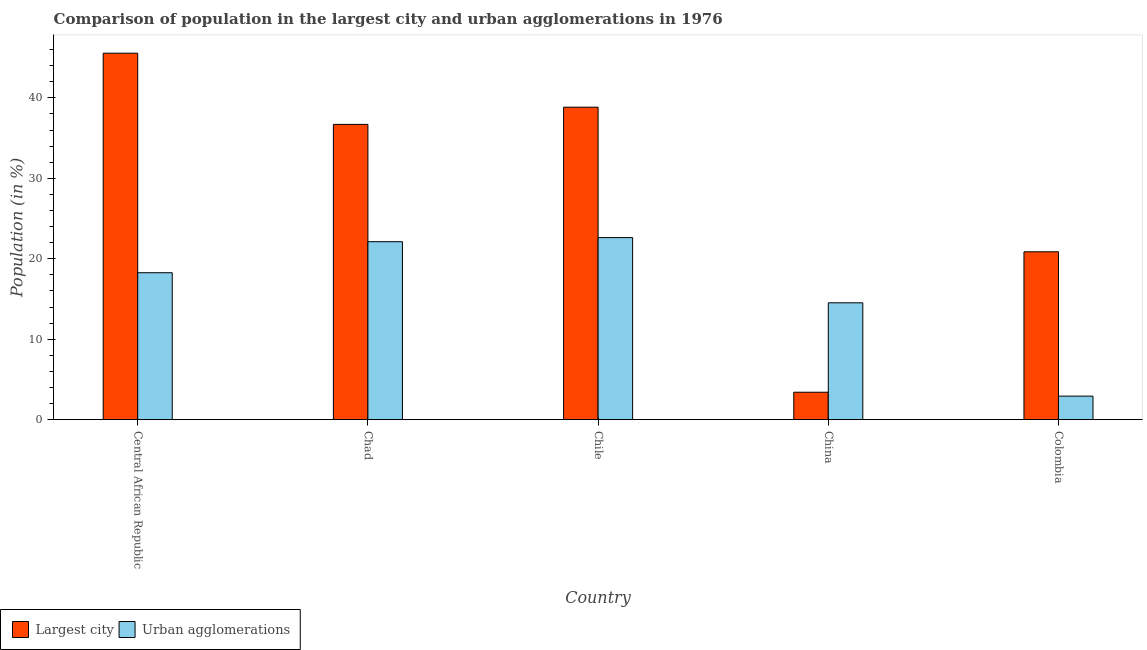Are the number of bars per tick equal to the number of legend labels?
Keep it short and to the point. Yes. In how many cases, is the number of bars for a given country not equal to the number of legend labels?
Your answer should be compact. 0. What is the population in urban agglomerations in Chile?
Provide a short and direct response. 22.63. Across all countries, what is the maximum population in the largest city?
Provide a succinct answer. 45.55. Across all countries, what is the minimum population in the largest city?
Give a very brief answer. 3.41. In which country was the population in urban agglomerations maximum?
Provide a short and direct response. Chile. In which country was the population in urban agglomerations minimum?
Provide a succinct answer. Colombia. What is the total population in the largest city in the graph?
Make the answer very short. 145.37. What is the difference between the population in urban agglomerations in Central African Republic and that in Chile?
Offer a very short reply. -4.37. What is the difference between the population in the largest city in China and the population in urban agglomerations in Central African Republic?
Ensure brevity in your answer.  -14.85. What is the average population in the largest city per country?
Offer a very short reply. 29.07. What is the difference between the population in urban agglomerations and population in the largest city in China?
Offer a very short reply. 11.11. In how many countries, is the population in the largest city greater than 32 %?
Give a very brief answer. 3. What is the ratio of the population in the largest city in Chile to that in China?
Offer a very short reply. 11.38. What is the difference between the highest and the second highest population in urban agglomerations?
Your answer should be compact. 0.51. What is the difference between the highest and the lowest population in urban agglomerations?
Your answer should be very brief. 19.7. What does the 1st bar from the left in Chad represents?
Make the answer very short. Largest city. What does the 2nd bar from the right in Colombia represents?
Your answer should be very brief. Largest city. How many bars are there?
Your answer should be very brief. 10. What is the difference between two consecutive major ticks on the Y-axis?
Offer a terse response. 10. Are the values on the major ticks of Y-axis written in scientific E-notation?
Provide a short and direct response. No. How are the legend labels stacked?
Your answer should be compact. Horizontal. What is the title of the graph?
Your response must be concise. Comparison of population in the largest city and urban agglomerations in 1976. Does "Birth rate" appear as one of the legend labels in the graph?
Provide a succinct answer. No. What is the Population (in %) in Largest city in Central African Republic?
Make the answer very short. 45.55. What is the Population (in %) in Urban agglomerations in Central African Republic?
Your answer should be very brief. 18.27. What is the Population (in %) of Largest city in Chad?
Make the answer very short. 36.7. What is the Population (in %) of Urban agglomerations in Chad?
Give a very brief answer. 22.12. What is the Population (in %) of Largest city in Chile?
Provide a succinct answer. 38.84. What is the Population (in %) in Urban agglomerations in Chile?
Make the answer very short. 22.63. What is the Population (in %) in Largest city in China?
Your response must be concise. 3.41. What is the Population (in %) of Urban agglomerations in China?
Your answer should be compact. 14.53. What is the Population (in %) of Largest city in Colombia?
Make the answer very short. 20.87. What is the Population (in %) of Urban agglomerations in Colombia?
Offer a very short reply. 2.93. Across all countries, what is the maximum Population (in %) of Largest city?
Provide a short and direct response. 45.55. Across all countries, what is the maximum Population (in %) in Urban agglomerations?
Offer a very short reply. 22.63. Across all countries, what is the minimum Population (in %) in Largest city?
Keep it short and to the point. 3.41. Across all countries, what is the minimum Population (in %) of Urban agglomerations?
Offer a very short reply. 2.93. What is the total Population (in %) of Largest city in the graph?
Provide a short and direct response. 145.37. What is the total Population (in %) of Urban agglomerations in the graph?
Make the answer very short. 80.48. What is the difference between the Population (in %) in Largest city in Central African Republic and that in Chad?
Ensure brevity in your answer.  8.85. What is the difference between the Population (in %) of Urban agglomerations in Central African Republic and that in Chad?
Provide a short and direct response. -3.86. What is the difference between the Population (in %) of Largest city in Central African Republic and that in Chile?
Provide a short and direct response. 6.71. What is the difference between the Population (in %) in Urban agglomerations in Central African Republic and that in Chile?
Keep it short and to the point. -4.37. What is the difference between the Population (in %) in Largest city in Central African Republic and that in China?
Your response must be concise. 42.13. What is the difference between the Population (in %) of Urban agglomerations in Central African Republic and that in China?
Your answer should be compact. 3.74. What is the difference between the Population (in %) in Largest city in Central African Republic and that in Colombia?
Ensure brevity in your answer.  24.68. What is the difference between the Population (in %) in Urban agglomerations in Central African Republic and that in Colombia?
Keep it short and to the point. 15.34. What is the difference between the Population (in %) of Largest city in Chad and that in Chile?
Provide a succinct answer. -2.14. What is the difference between the Population (in %) in Urban agglomerations in Chad and that in Chile?
Your answer should be very brief. -0.51. What is the difference between the Population (in %) of Largest city in Chad and that in China?
Give a very brief answer. 33.29. What is the difference between the Population (in %) of Urban agglomerations in Chad and that in China?
Your answer should be compact. 7.59. What is the difference between the Population (in %) in Largest city in Chad and that in Colombia?
Your response must be concise. 15.83. What is the difference between the Population (in %) in Urban agglomerations in Chad and that in Colombia?
Your answer should be compact. 19.19. What is the difference between the Population (in %) in Largest city in Chile and that in China?
Ensure brevity in your answer.  35.42. What is the difference between the Population (in %) in Urban agglomerations in Chile and that in China?
Provide a short and direct response. 8.1. What is the difference between the Population (in %) of Largest city in Chile and that in Colombia?
Provide a succinct answer. 17.97. What is the difference between the Population (in %) in Urban agglomerations in Chile and that in Colombia?
Ensure brevity in your answer.  19.7. What is the difference between the Population (in %) in Largest city in China and that in Colombia?
Ensure brevity in your answer.  -17.45. What is the difference between the Population (in %) of Urban agglomerations in China and that in Colombia?
Keep it short and to the point. 11.6. What is the difference between the Population (in %) in Largest city in Central African Republic and the Population (in %) in Urban agglomerations in Chad?
Offer a very short reply. 23.43. What is the difference between the Population (in %) in Largest city in Central African Republic and the Population (in %) in Urban agglomerations in Chile?
Keep it short and to the point. 22.92. What is the difference between the Population (in %) in Largest city in Central African Republic and the Population (in %) in Urban agglomerations in China?
Your answer should be very brief. 31.02. What is the difference between the Population (in %) in Largest city in Central African Republic and the Population (in %) in Urban agglomerations in Colombia?
Provide a short and direct response. 42.62. What is the difference between the Population (in %) in Largest city in Chad and the Population (in %) in Urban agglomerations in Chile?
Offer a terse response. 14.07. What is the difference between the Population (in %) in Largest city in Chad and the Population (in %) in Urban agglomerations in China?
Keep it short and to the point. 22.17. What is the difference between the Population (in %) in Largest city in Chad and the Population (in %) in Urban agglomerations in Colombia?
Provide a succinct answer. 33.77. What is the difference between the Population (in %) of Largest city in Chile and the Population (in %) of Urban agglomerations in China?
Your answer should be very brief. 24.31. What is the difference between the Population (in %) of Largest city in Chile and the Population (in %) of Urban agglomerations in Colombia?
Your answer should be very brief. 35.91. What is the difference between the Population (in %) of Largest city in China and the Population (in %) of Urban agglomerations in Colombia?
Give a very brief answer. 0.48. What is the average Population (in %) of Largest city per country?
Offer a very short reply. 29.07. What is the average Population (in %) of Urban agglomerations per country?
Your response must be concise. 16.1. What is the difference between the Population (in %) of Largest city and Population (in %) of Urban agglomerations in Central African Republic?
Your response must be concise. 27.28. What is the difference between the Population (in %) in Largest city and Population (in %) in Urban agglomerations in Chad?
Make the answer very short. 14.58. What is the difference between the Population (in %) in Largest city and Population (in %) in Urban agglomerations in Chile?
Ensure brevity in your answer.  16.21. What is the difference between the Population (in %) of Largest city and Population (in %) of Urban agglomerations in China?
Offer a terse response. -11.11. What is the difference between the Population (in %) of Largest city and Population (in %) of Urban agglomerations in Colombia?
Offer a very short reply. 17.94. What is the ratio of the Population (in %) in Largest city in Central African Republic to that in Chad?
Make the answer very short. 1.24. What is the ratio of the Population (in %) in Urban agglomerations in Central African Republic to that in Chad?
Offer a very short reply. 0.83. What is the ratio of the Population (in %) of Largest city in Central African Republic to that in Chile?
Offer a very short reply. 1.17. What is the ratio of the Population (in %) in Urban agglomerations in Central African Republic to that in Chile?
Provide a succinct answer. 0.81. What is the ratio of the Population (in %) of Largest city in Central African Republic to that in China?
Offer a terse response. 13.34. What is the ratio of the Population (in %) in Urban agglomerations in Central African Republic to that in China?
Give a very brief answer. 1.26. What is the ratio of the Population (in %) of Largest city in Central African Republic to that in Colombia?
Offer a very short reply. 2.18. What is the ratio of the Population (in %) in Urban agglomerations in Central African Republic to that in Colombia?
Your response must be concise. 6.23. What is the ratio of the Population (in %) in Largest city in Chad to that in Chile?
Provide a succinct answer. 0.94. What is the ratio of the Population (in %) in Urban agglomerations in Chad to that in Chile?
Make the answer very short. 0.98. What is the ratio of the Population (in %) in Largest city in Chad to that in China?
Provide a short and direct response. 10.75. What is the ratio of the Population (in %) in Urban agglomerations in Chad to that in China?
Your answer should be very brief. 1.52. What is the ratio of the Population (in %) of Largest city in Chad to that in Colombia?
Your answer should be very brief. 1.76. What is the ratio of the Population (in %) of Urban agglomerations in Chad to that in Colombia?
Offer a very short reply. 7.55. What is the ratio of the Population (in %) of Largest city in Chile to that in China?
Offer a terse response. 11.38. What is the ratio of the Population (in %) of Urban agglomerations in Chile to that in China?
Offer a terse response. 1.56. What is the ratio of the Population (in %) of Largest city in Chile to that in Colombia?
Keep it short and to the point. 1.86. What is the ratio of the Population (in %) in Urban agglomerations in Chile to that in Colombia?
Provide a succinct answer. 7.72. What is the ratio of the Population (in %) of Largest city in China to that in Colombia?
Offer a terse response. 0.16. What is the ratio of the Population (in %) in Urban agglomerations in China to that in Colombia?
Make the answer very short. 4.96. What is the difference between the highest and the second highest Population (in %) of Largest city?
Make the answer very short. 6.71. What is the difference between the highest and the second highest Population (in %) of Urban agglomerations?
Ensure brevity in your answer.  0.51. What is the difference between the highest and the lowest Population (in %) in Largest city?
Give a very brief answer. 42.13. What is the difference between the highest and the lowest Population (in %) in Urban agglomerations?
Give a very brief answer. 19.7. 